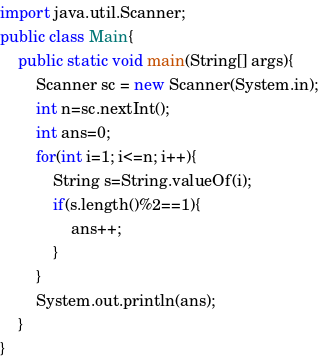<code> <loc_0><loc_0><loc_500><loc_500><_Java_>import java.util.Scanner;
public class Main{
	public static void main(String[] args){
		Scanner sc = new Scanner(System.in);
		int n=sc.nextInt();
		int ans=0;
		for(int i=1; i<=n; i++){
			String s=String.valueOf(i);
			if(s.length()%2==1){
				ans++;
			}
		}
		System.out.println(ans);
	}
}
</code> 